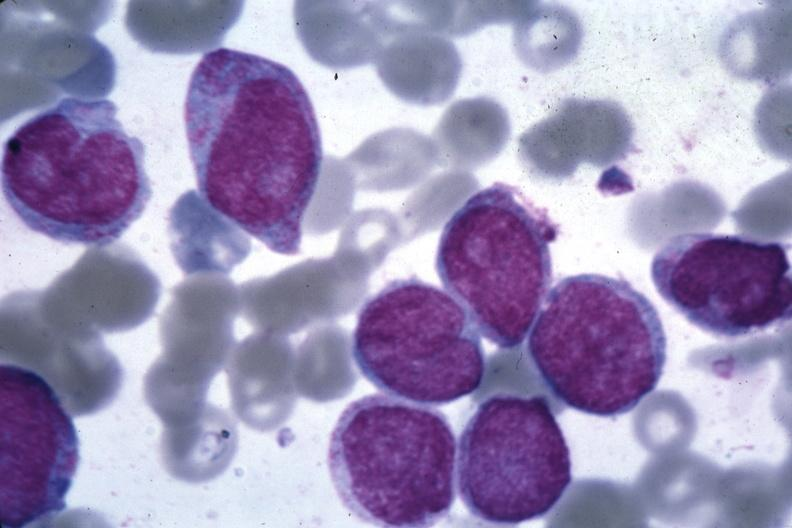does leiomyosarcoma show oil wrights good photo blast cells?
Answer the question using a single word or phrase. No 